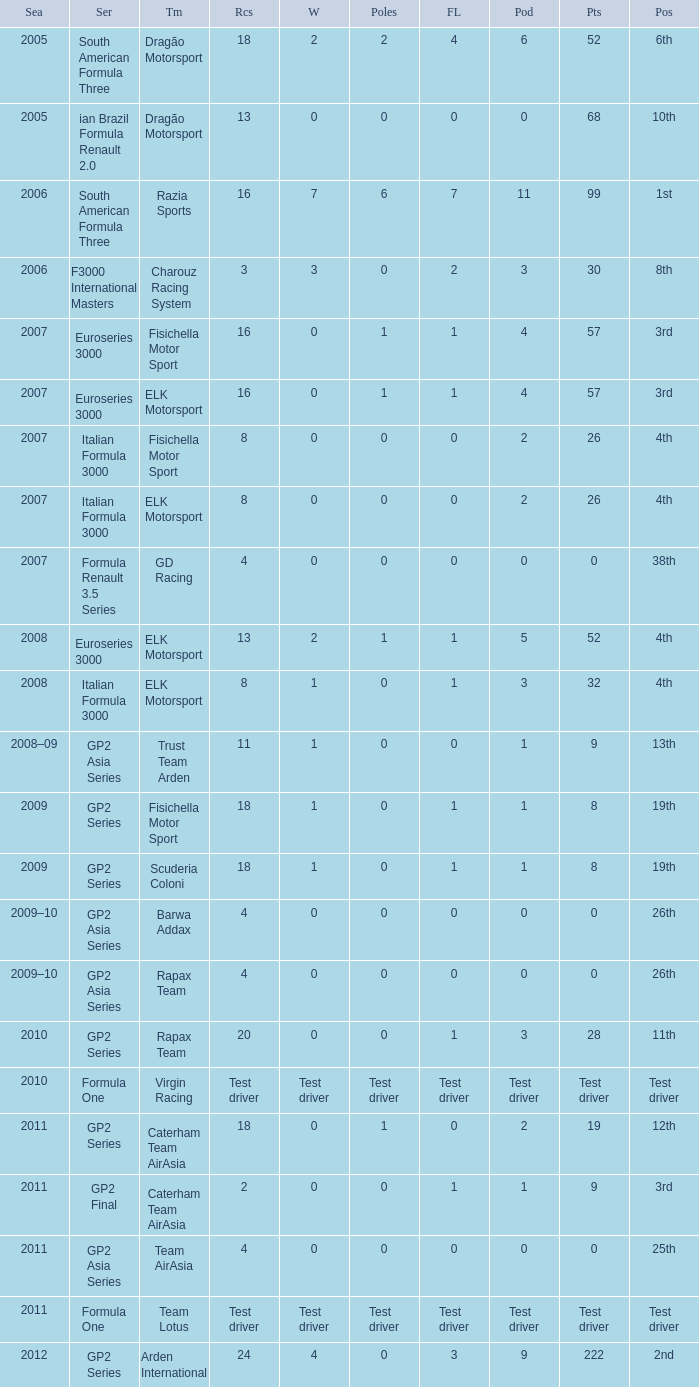What were the points in the year when his Wins were 0, his Podiums were 0, and he drove in 4 races? 0, 0, 0, 0. Write the full table. {'header': ['Sea', 'Ser', 'Tm', 'Rcs', 'W', 'Poles', 'FL', 'Pod', 'Pts', 'Pos'], 'rows': [['2005', 'South American Formula Three', 'Dragão Motorsport', '18', '2', '2', '4', '6', '52', '6th'], ['2005', 'ian Brazil Formula Renault 2.0', 'Dragão Motorsport', '13', '0', '0', '0', '0', '68', '10th'], ['2006', 'South American Formula Three', 'Razia Sports', '16', '7', '6', '7', '11', '99', '1st'], ['2006', 'F3000 International Masters', 'Charouz Racing System', '3', '3', '0', '2', '3', '30', '8th'], ['2007', 'Euroseries 3000', 'Fisichella Motor Sport', '16', '0', '1', '1', '4', '57', '3rd'], ['2007', 'Euroseries 3000', 'ELK Motorsport', '16', '0', '1', '1', '4', '57', '3rd'], ['2007', 'Italian Formula 3000', 'Fisichella Motor Sport', '8', '0', '0', '0', '2', '26', '4th'], ['2007', 'Italian Formula 3000', 'ELK Motorsport', '8', '0', '0', '0', '2', '26', '4th'], ['2007', 'Formula Renault 3.5 Series', 'GD Racing', '4', '0', '0', '0', '0', '0', '38th'], ['2008', 'Euroseries 3000', 'ELK Motorsport', '13', '2', '1', '1', '5', '52', '4th'], ['2008', 'Italian Formula 3000', 'ELK Motorsport', '8', '1', '0', '1', '3', '32', '4th'], ['2008–09', 'GP2 Asia Series', 'Trust Team Arden', '11', '1', '0', '0', '1', '9', '13th'], ['2009', 'GP2 Series', 'Fisichella Motor Sport', '18', '1', '0', '1', '1', '8', '19th'], ['2009', 'GP2 Series', 'Scuderia Coloni', '18', '1', '0', '1', '1', '8', '19th'], ['2009–10', 'GP2 Asia Series', 'Barwa Addax', '4', '0', '0', '0', '0', '0', '26th'], ['2009–10', 'GP2 Asia Series', 'Rapax Team', '4', '0', '0', '0', '0', '0', '26th'], ['2010', 'GP2 Series', 'Rapax Team', '20', '0', '0', '1', '3', '28', '11th'], ['2010', 'Formula One', 'Virgin Racing', 'Test driver', 'Test driver', 'Test driver', 'Test driver', 'Test driver', 'Test driver', 'Test driver'], ['2011', 'GP2 Series', 'Caterham Team AirAsia', '18', '0', '1', '0', '2', '19', '12th'], ['2011', 'GP2 Final', 'Caterham Team AirAsia', '2', '0', '0', '1', '1', '9', '3rd'], ['2011', 'GP2 Asia Series', 'Team AirAsia', '4', '0', '0', '0', '0', '0', '25th'], ['2011', 'Formula One', 'Team Lotus', 'Test driver', 'Test driver', 'Test driver', 'Test driver', 'Test driver', 'Test driver', 'Test driver'], ['2012', 'GP2 Series', 'Arden International', '24', '4', '0', '3', '9', '222', '2nd']]} 